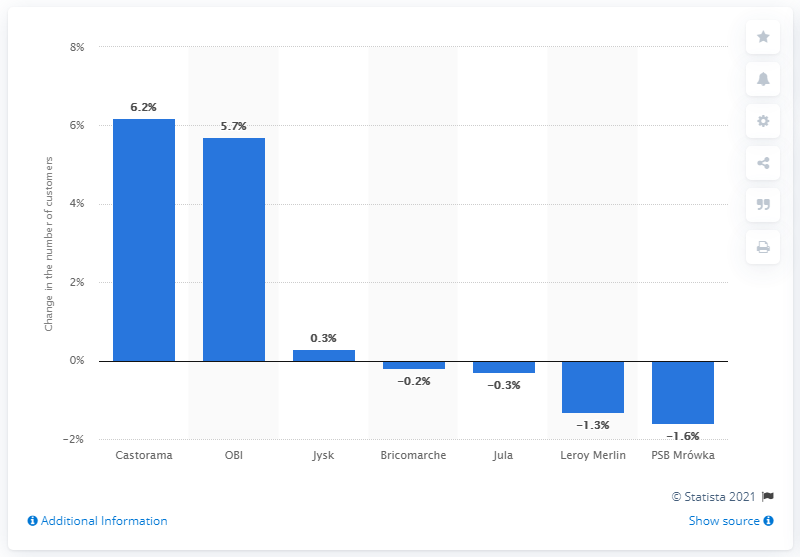Indicate a few pertinent items in this graphic. Castorama's customers increased by 6.2% between 20 February and 19 March. 